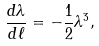Convert formula to latex. <formula><loc_0><loc_0><loc_500><loc_500>\frac { d \lambda } { d \ell } = - \frac { 1 } { 2 } \lambda ^ { 3 } ,</formula> 